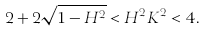<formula> <loc_0><loc_0><loc_500><loc_500>2 + 2 \sqrt { 1 - H ^ { 2 } } < H ^ { 2 } K ^ { 2 } < 4 .</formula> 